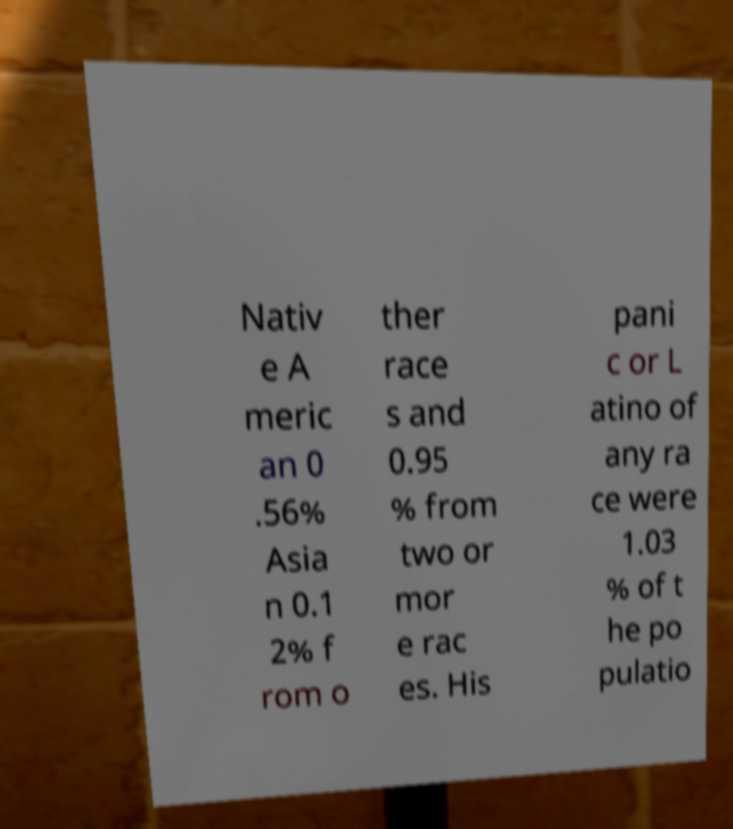Please read and relay the text visible in this image. What does it say? Nativ e A meric an 0 .56% Asia n 0.1 2% f rom o ther race s and 0.95 % from two or mor e rac es. His pani c or L atino of any ra ce were 1.03 % of t he po pulatio 